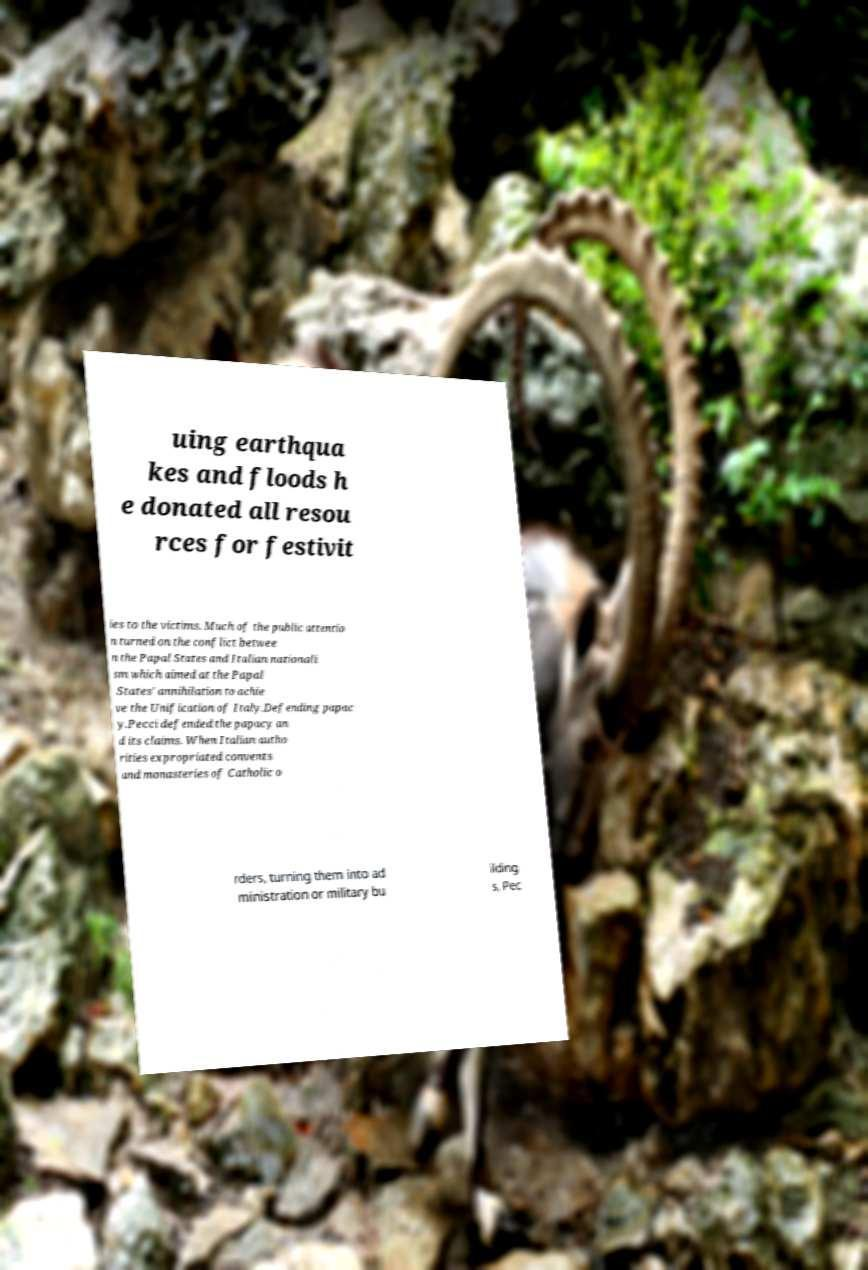What messages or text are displayed in this image? I need them in a readable, typed format. uing earthqua kes and floods h e donated all resou rces for festivit ies to the victims. Much of the public attentio n turned on the conflict betwee n the Papal States and Italian nationali sm which aimed at the Papal States' annihilation to achie ve the Unification of Italy.Defending papac y.Pecci defended the papacy an d its claims. When Italian autho rities expropriated convents and monasteries of Catholic o rders, turning them into ad ministration or military bu ilding s, Pec 